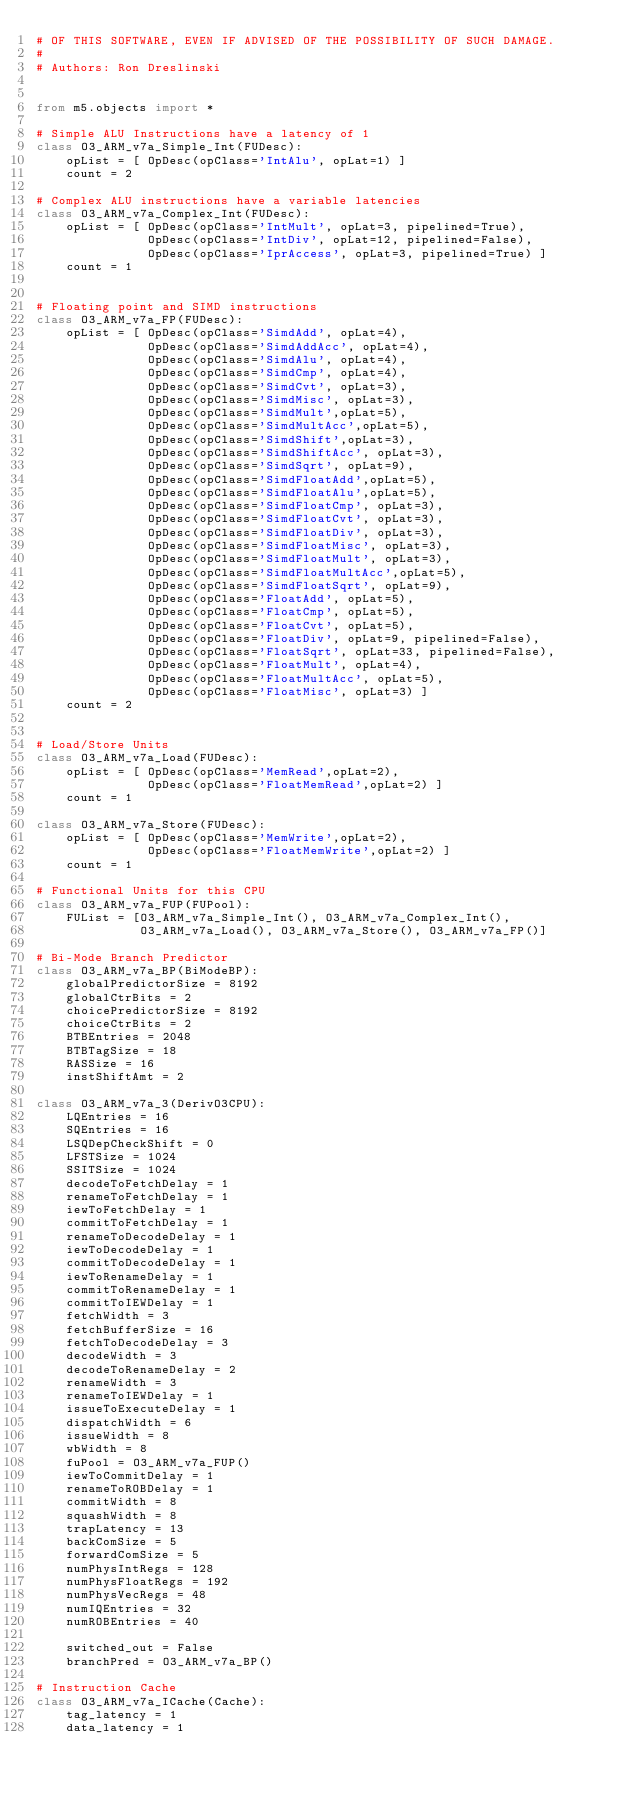<code> <loc_0><loc_0><loc_500><loc_500><_Python_># OF THIS SOFTWARE, EVEN IF ADVISED OF THE POSSIBILITY OF SUCH DAMAGE.
#
# Authors: Ron Dreslinski


from m5.objects import *

# Simple ALU Instructions have a latency of 1
class O3_ARM_v7a_Simple_Int(FUDesc):
    opList = [ OpDesc(opClass='IntAlu', opLat=1) ]
    count = 2

# Complex ALU instructions have a variable latencies
class O3_ARM_v7a_Complex_Int(FUDesc):
    opList = [ OpDesc(opClass='IntMult', opLat=3, pipelined=True),
               OpDesc(opClass='IntDiv', opLat=12, pipelined=False),
               OpDesc(opClass='IprAccess', opLat=3, pipelined=True) ]
    count = 1


# Floating point and SIMD instructions
class O3_ARM_v7a_FP(FUDesc):
    opList = [ OpDesc(opClass='SimdAdd', opLat=4),
               OpDesc(opClass='SimdAddAcc', opLat=4),
               OpDesc(opClass='SimdAlu', opLat=4),
               OpDesc(opClass='SimdCmp', opLat=4),
               OpDesc(opClass='SimdCvt', opLat=3),
               OpDesc(opClass='SimdMisc', opLat=3),
               OpDesc(opClass='SimdMult',opLat=5),
               OpDesc(opClass='SimdMultAcc',opLat=5),
               OpDesc(opClass='SimdShift',opLat=3),
               OpDesc(opClass='SimdShiftAcc', opLat=3),
               OpDesc(opClass='SimdSqrt', opLat=9),
               OpDesc(opClass='SimdFloatAdd',opLat=5),
               OpDesc(opClass='SimdFloatAlu',opLat=5),
               OpDesc(opClass='SimdFloatCmp', opLat=3),
               OpDesc(opClass='SimdFloatCvt', opLat=3),
               OpDesc(opClass='SimdFloatDiv', opLat=3),
               OpDesc(opClass='SimdFloatMisc', opLat=3),
               OpDesc(opClass='SimdFloatMult', opLat=3),
               OpDesc(opClass='SimdFloatMultAcc',opLat=5),
               OpDesc(opClass='SimdFloatSqrt', opLat=9),
               OpDesc(opClass='FloatAdd', opLat=5),
               OpDesc(opClass='FloatCmp', opLat=5),
               OpDesc(opClass='FloatCvt', opLat=5),
               OpDesc(opClass='FloatDiv', opLat=9, pipelined=False),
               OpDesc(opClass='FloatSqrt', opLat=33, pipelined=False),
               OpDesc(opClass='FloatMult', opLat=4),
               OpDesc(opClass='FloatMultAcc', opLat=5),
               OpDesc(opClass='FloatMisc', opLat=3) ]
    count = 2


# Load/Store Units
class O3_ARM_v7a_Load(FUDesc):
    opList = [ OpDesc(opClass='MemRead',opLat=2),
               OpDesc(opClass='FloatMemRead',opLat=2) ]
    count = 1

class O3_ARM_v7a_Store(FUDesc):
    opList = [ OpDesc(opClass='MemWrite',opLat=2),
               OpDesc(opClass='FloatMemWrite',opLat=2) ]
    count = 1

# Functional Units for this CPU
class O3_ARM_v7a_FUP(FUPool):
    FUList = [O3_ARM_v7a_Simple_Int(), O3_ARM_v7a_Complex_Int(),
              O3_ARM_v7a_Load(), O3_ARM_v7a_Store(), O3_ARM_v7a_FP()]

# Bi-Mode Branch Predictor
class O3_ARM_v7a_BP(BiModeBP):
    globalPredictorSize = 8192
    globalCtrBits = 2
    choicePredictorSize = 8192
    choiceCtrBits = 2
    BTBEntries = 2048
    BTBTagSize = 18
    RASSize = 16
    instShiftAmt = 2

class O3_ARM_v7a_3(DerivO3CPU):
    LQEntries = 16
    SQEntries = 16
    LSQDepCheckShift = 0
    LFSTSize = 1024
    SSITSize = 1024
    decodeToFetchDelay = 1
    renameToFetchDelay = 1
    iewToFetchDelay = 1
    commitToFetchDelay = 1
    renameToDecodeDelay = 1
    iewToDecodeDelay = 1
    commitToDecodeDelay = 1
    iewToRenameDelay = 1
    commitToRenameDelay = 1
    commitToIEWDelay = 1
    fetchWidth = 3
    fetchBufferSize = 16
    fetchToDecodeDelay = 3
    decodeWidth = 3
    decodeToRenameDelay = 2
    renameWidth = 3
    renameToIEWDelay = 1
    issueToExecuteDelay = 1
    dispatchWidth = 6
    issueWidth = 8
    wbWidth = 8
    fuPool = O3_ARM_v7a_FUP()
    iewToCommitDelay = 1
    renameToROBDelay = 1
    commitWidth = 8
    squashWidth = 8
    trapLatency = 13
    backComSize = 5
    forwardComSize = 5
    numPhysIntRegs = 128
    numPhysFloatRegs = 192
    numPhysVecRegs = 48
    numIQEntries = 32
    numROBEntries = 40

    switched_out = False
    branchPred = O3_ARM_v7a_BP()

# Instruction Cache
class O3_ARM_v7a_ICache(Cache):
    tag_latency = 1
    data_latency = 1</code> 